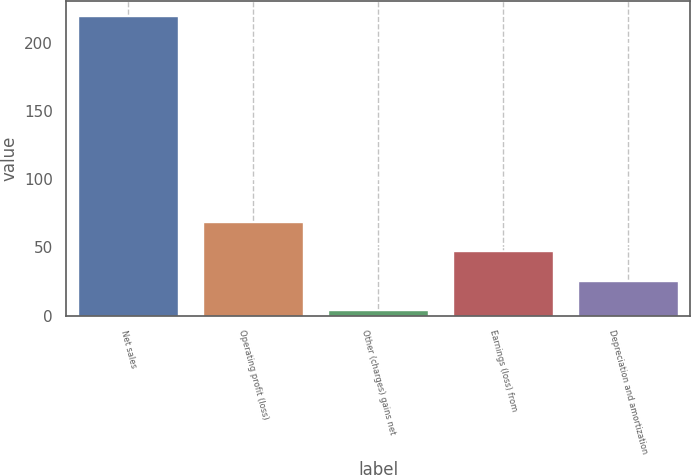Convert chart to OTSL. <chart><loc_0><loc_0><loc_500><loc_500><bar_chart><fcel>Net sales<fcel>Operating profit (loss)<fcel>Other (charges) gains net<fcel>Earnings (loss) from<fcel>Depreciation and amortization<nl><fcel>220<fcel>68.8<fcel>4<fcel>47.2<fcel>25.6<nl></chart> 